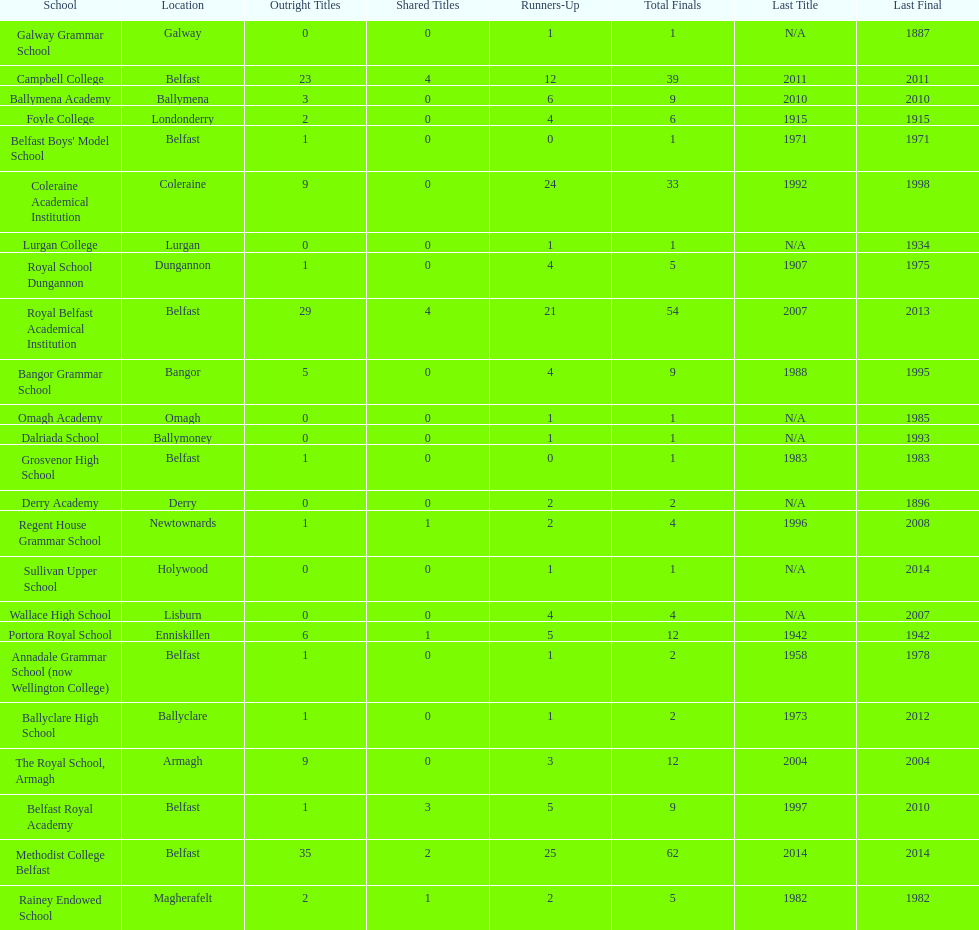Would you mind parsing the complete table? {'header': ['School', 'Location', 'Outright Titles', 'Shared Titles', 'Runners-Up', 'Total Finals', 'Last Title', 'Last Final'], 'rows': [['Galway Grammar School', 'Galway', '0', '0', '1', '1', 'N/A', '1887'], ['Campbell College', 'Belfast', '23', '4', '12', '39', '2011', '2011'], ['Ballymena Academy', 'Ballymena', '3', '0', '6', '9', '2010', '2010'], ['Foyle College', 'Londonderry', '2', '0', '4', '6', '1915', '1915'], ["Belfast Boys' Model School", 'Belfast', '1', '0', '0', '1', '1971', '1971'], ['Coleraine Academical Institution', 'Coleraine', '9', '0', '24', '33', '1992', '1998'], ['Lurgan College', 'Lurgan', '0', '0', '1', '1', 'N/A', '1934'], ['Royal School Dungannon', 'Dungannon', '1', '0', '4', '5', '1907', '1975'], ['Royal Belfast Academical Institution', 'Belfast', '29', '4', '21', '54', '2007', '2013'], ['Bangor Grammar School', 'Bangor', '5', '0', '4', '9', '1988', '1995'], ['Omagh Academy', 'Omagh', '0', '0', '1', '1', 'N/A', '1985'], ['Dalriada School', 'Ballymoney', '0', '0', '1', '1', 'N/A', '1993'], ['Grosvenor High School', 'Belfast', '1', '0', '0', '1', '1983', '1983'], ['Derry Academy', 'Derry', '0', '0', '2', '2', 'N/A', '1896'], ['Regent House Grammar School', 'Newtownards', '1', '1', '2', '4', '1996', '2008'], ['Sullivan Upper School', 'Holywood', '0', '0', '1', '1', 'N/A', '2014'], ['Wallace High School', 'Lisburn', '0', '0', '4', '4', 'N/A', '2007'], ['Portora Royal School', 'Enniskillen', '6', '1', '5', '12', '1942', '1942'], ['Annadale Grammar School (now Wellington College)', 'Belfast', '1', '0', '1', '2', '1958', '1978'], ['Ballyclare High School', 'Ballyclare', '1', '0', '1', '2', '1973', '2012'], ['The Royal School, Armagh', 'Armagh', '9', '0', '3', '12', '2004', '2004'], ['Belfast Royal Academy', 'Belfast', '1', '3', '5', '9', '1997', '2010'], ['Methodist College Belfast', 'Belfast', '35', '2', '25', '62', '2014', '2014'], ['Rainey Endowed School', 'Magherafelt', '2', '1', '2', '5', '1982', '1982']]} Which pair of schools both had a dozen finals altogether? The Royal School, Armagh, Portora Royal School. 